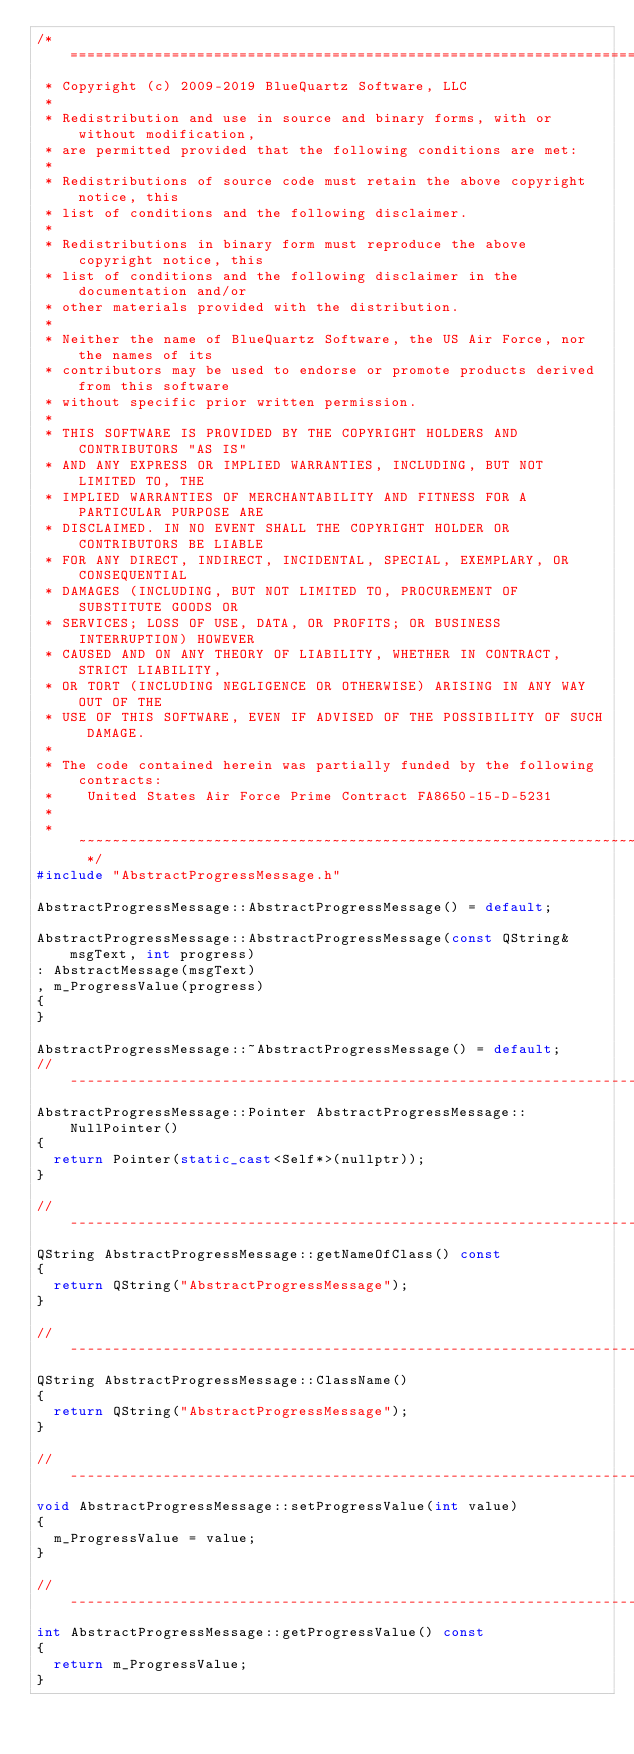<code> <loc_0><loc_0><loc_500><loc_500><_C++_>/* ============================================================================
 * Copyright (c) 2009-2019 BlueQuartz Software, LLC
 *
 * Redistribution and use in source and binary forms, with or without modification,
 * are permitted provided that the following conditions are met:
 *
 * Redistributions of source code must retain the above copyright notice, this
 * list of conditions and the following disclaimer.
 *
 * Redistributions in binary form must reproduce the above copyright notice, this
 * list of conditions and the following disclaimer in the documentation and/or
 * other materials provided with the distribution.
 *
 * Neither the name of BlueQuartz Software, the US Air Force, nor the names of its
 * contributors may be used to endorse or promote products derived from this software
 * without specific prior written permission.
 *
 * THIS SOFTWARE IS PROVIDED BY THE COPYRIGHT HOLDERS AND CONTRIBUTORS "AS IS"
 * AND ANY EXPRESS OR IMPLIED WARRANTIES, INCLUDING, BUT NOT LIMITED TO, THE
 * IMPLIED WARRANTIES OF MERCHANTABILITY AND FITNESS FOR A PARTICULAR PURPOSE ARE
 * DISCLAIMED. IN NO EVENT SHALL THE COPYRIGHT HOLDER OR CONTRIBUTORS BE LIABLE
 * FOR ANY DIRECT, INDIRECT, INCIDENTAL, SPECIAL, EXEMPLARY, OR CONSEQUENTIAL
 * DAMAGES (INCLUDING, BUT NOT LIMITED TO, PROCUREMENT OF SUBSTITUTE GOODS OR
 * SERVICES; LOSS OF USE, DATA, OR PROFITS; OR BUSINESS INTERRUPTION) HOWEVER
 * CAUSED AND ON ANY THEORY OF LIABILITY, WHETHER IN CONTRACT, STRICT LIABILITY,
 * OR TORT (INCLUDING NEGLIGENCE OR OTHERWISE) ARISING IN ANY WAY OUT OF THE
 * USE OF THIS SOFTWARE, EVEN IF ADVISED OF THE POSSIBILITY OF SUCH DAMAGE.
 *
 * The code contained herein was partially funded by the following contracts:
 *    United States Air Force Prime Contract FA8650-15-D-5231
 *
 * ~~~~~~~~~~~~~~~~~~~~~~~~~~~~~~~~~~~~~~~~~~~~~~~~~~~~~~~~~~~~~~~~~~~~~~~~~~ */
#include "AbstractProgressMessage.h"

AbstractProgressMessage::AbstractProgressMessage() = default;

AbstractProgressMessage::AbstractProgressMessage(const QString& msgText, int progress)
: AbstractMessage(msgText)
, m_ProgressValue(progress)
{
}

AbstractProgressMessage::~AbstractProgressMessage() = default;
// -----------------------------------------------------------------------------
AbstractProgressMessage::Pointer AbstractProgressMessage::NullPointer()
{
  return Pointer(static_cast<Self*>(nullptr));
}

// -----------------------------------------------------------------------------
QString AbstractProgressMessage::getNameOfClass() const
{
  return QString("AbstractProgressMessage");
}

// -----------------------------------------------------------------------------
QString AbstractProgressMessage::ClassName()
{
  return QString("AbstractProgressMessage");
}

// -----------------------------------------------------------------------------
void AbstractProgressMessage::setProgressValue(int value)
{
  m_ProgressValue = value;
}

// -----------------------------------------------------------------------------
int AbstractProgressMessage::getProgressValue() const
{
  return m_ProgressValue;
}
</code> 